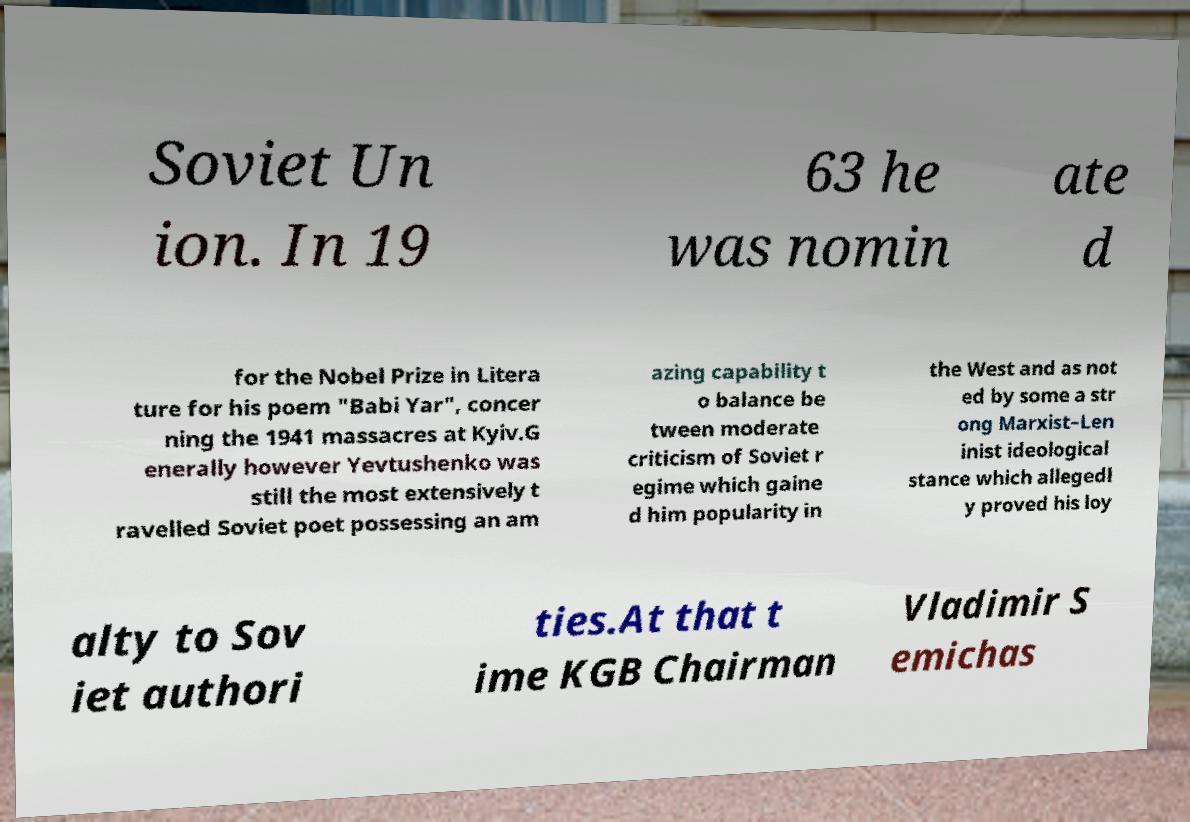Please read and relay the text visible in this image. What does it say? Soviet Un ion. In 19 63 he was nomin ate d for the Nobel Prize in Litera ture for his poem "Babi Yar", concer ning the 1941 massacres at Kyiv.G enerally however Yevtushenko was still the most extensively t ravelled Soviet poet possessing an am azing capability t o balance be tween moderate criticism of Soviet r egime which gaine d him popularity in the West and as not ed by some a str ong Marxist–Len inist ideological stance which allegedl y proved his loy alty to Sov iet authori ties.At that t ime KGB Chairman Vladimir S emichas 